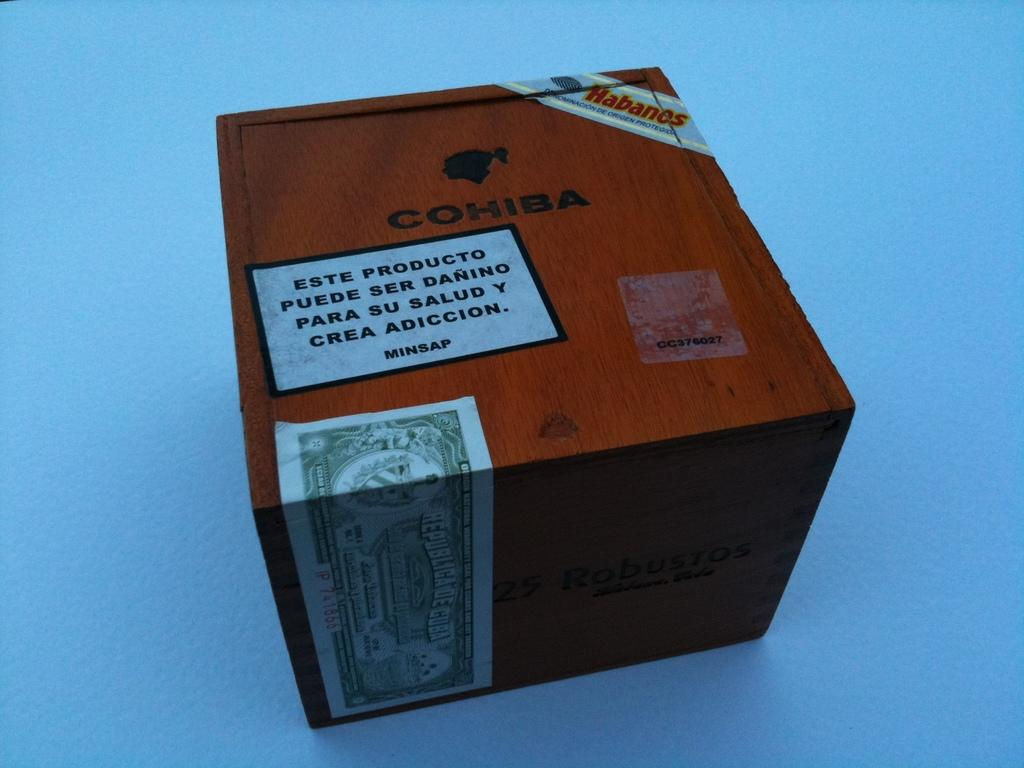<image>
Describe the image concisely. Brown box with a dollar bill on it and the word COHIBA as well. 